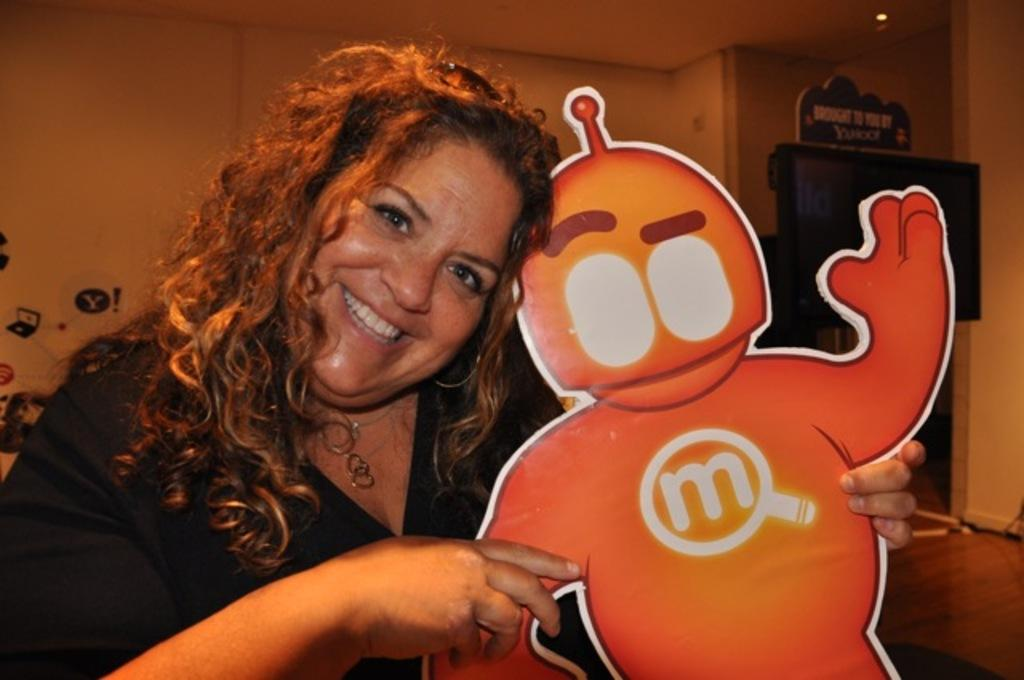Provide a one-sentence caption for the provided image. A girl is holding an orange figure with an M on it's chest. 